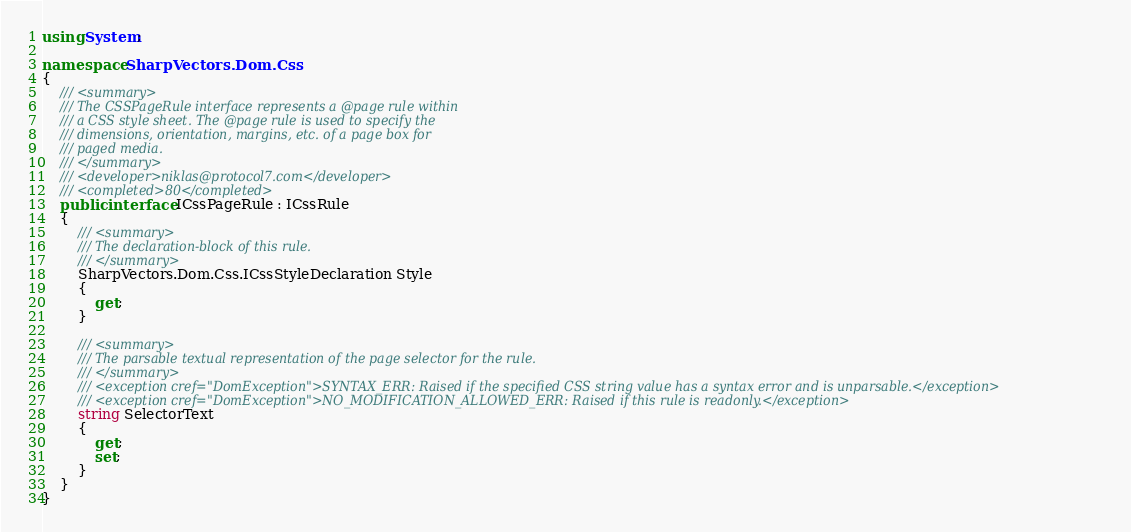Convert code to text. <code><loc_0><loc_0><loc_500><loc_500><_C#_>using System;

namespace SharpVectors.Dom.Css
{
	/// <summary>
	/// The CSSPageRule interface represents a @page rule within
	/// a CSS style sheet. The @page rule is used to specify the
	/// dimensions, orientation, margins, etc. of a page box for
	/// paged media. 
	/// </summary>
	/// <developer>niklas@protocol7.com</developer>
	/// <completed>80</completed>	
	public interface ICssPageRule : ICssRule
	{
		/// <summary>
		/// The declaration-block of this rule.
		/// </summary>
		SharpVectors.Dom.Css.ICssStyleDeclaration Style
		{
			get;
		}
	
		/// <summary>
		/// The parsable textual representation of the page selector for the rule.
		/// </summary>
		/// <exception cref="DomException">SYNTAX_ERR: Raised if the specified CSS string value has a syntax error and is unparsable.</exception>
		/// <exception cref="DomException">NO_MODIFICATION_ALLOWED_ERR: Raised if this rule is readonly.</exception>
		string SelectorText
		{
			get;
			set;
		}
	}
}
</code> 